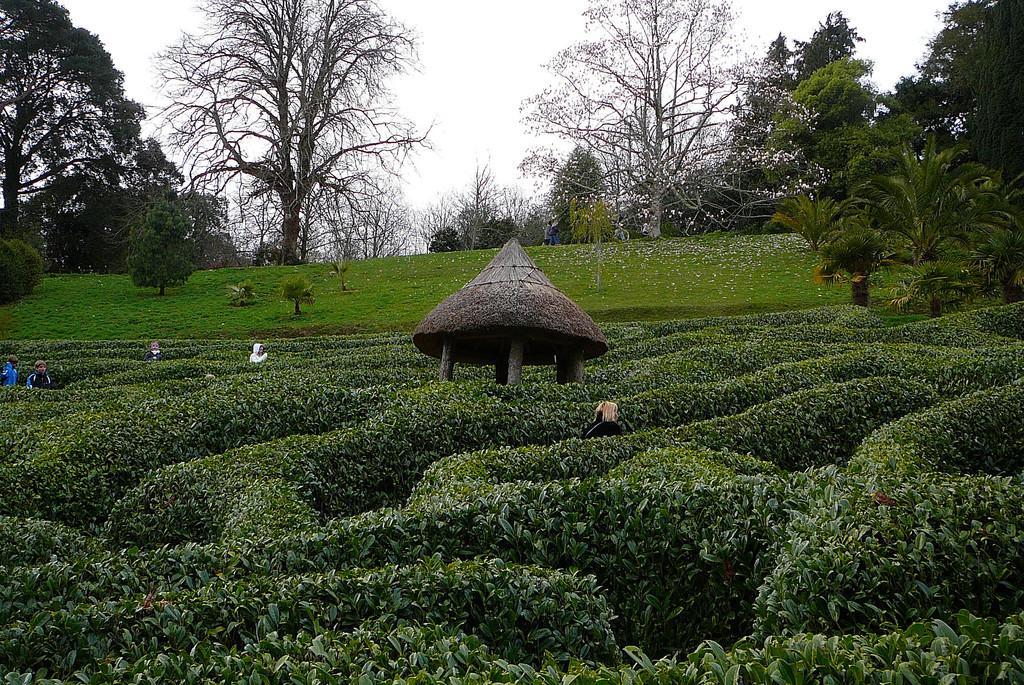How would you summarize this image in a sentence or two? In this image I can see in the middle there are bushes, on the left side two persons are there. At the back side there are trees, at the top it is the cloudy sky. In the middle it looks like a hut. 